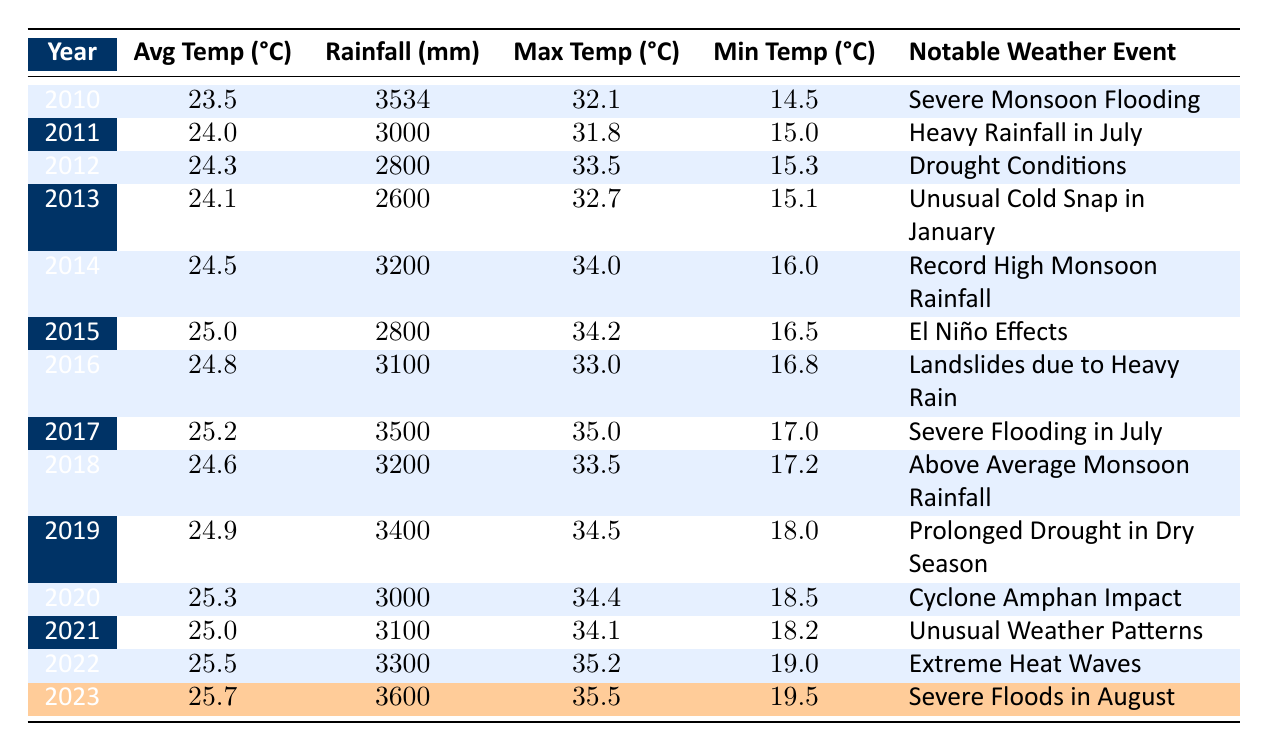What was the total rainfall in 2014? The table shows that the total rainfall in 2014 is listed as 3200 mm.
Answer: 3200 mm Which year had the highest maximum temperature? By looking at the 'Max Temp' column, the highest value is 35.5°C in 2023.
Answer: 2023 In which year did severe monsoon flooding occur? The notable weather event for 2010 is "Severe Monsoon Flooding."
Answer: 2010 What is the average temperature in the table for 2012 and 2023 combined? The average temperature in 2012 is 24.3°C and in 2023 is 25.7°C. The sum is (24.3 + 25.7) = 50.0. Dividing by 2 gives an average of 50.0/2 = 25.0°C.
Answer: 25.0°C Was the total rainfall in 2015 higher than in 2013? The total rainfall for 2015 is 2800 mm, and for 2013 is 2600 mm. Since 2800 mm is greater than 2600 mm, the statement is true.
Answer: Yes How much did the average temperature increase from 2010 to 2023? The average temperature in 2010 is 23.5°C and in 2023 it is 25.7°C. The increase can be calculated as (25.7 - 23.5) = 2.2°C.
Answer: 2.2°C What notable weather event occurred in 2021? The table states that the notable weather event for 2021 is "Unusual Weather Patterns."
Answer: Unusual Weather Patterns Which year had the lowest average temperature? By checking the 'Avg Temp' column, the lowest average temperature is 23.5°C in 2010.
Answer: 2010 How many years experienced total rainfall above 3500 mm? The years with total rainfall above 3500 mm are 2010 (3534 mm), 2017 (3500 mm), 2023 (3600 mm). Three years experienced this level of rainfall above 3500 mm.
Answer: 3 years What is the trend of average temperature from 2010 to 2023? The average temperatures show an increasing trend from 23.5°C in 2010 to 25.7°C in 2023, indicating a rise over the period.
Answer: Increasing trend 